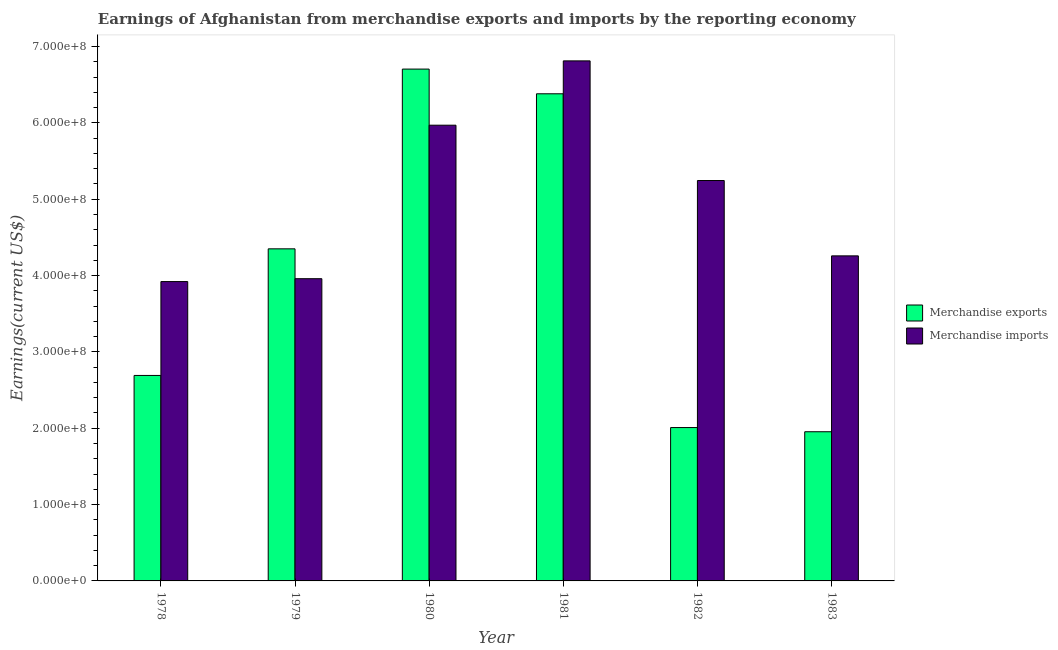How many different coloured bars are there?
Your answer should be very brief. 2. Are the number of bars on each tick of the X-axis equal?
Provide a succinct answer. Yes. How many bars are there on the 1st tick from the left?
Your answer should be compact. 2. What is the label of the 2nd group of bars from the left?
Keep it short and to the point. 1979. What is the earnings from merchandise exports in 1982?
Ensure brevity in your answer.  2.01e+08. Across all years, what is the maximum earnings from merchandise exports?
Provide a succinct answer. 6.70e+08. Across all years, what is the minimum earnings from merchandise imports?
Offer a very short reply. 3.92e+08. In which year was the earnings from merchandise exports maximum?
Ensure brevity in your answer.  1980. In which year was the earnings from merchandise imports minimum?
Keep it short and to the point. 1978. What is the total earnings from merchandise exports in the graph?
Provide a succinct answer. 2.41e+09. What is the difference between the earnings from merchandise imports in 1978 and that in 1980?
Your answer should be very brief. -2.05e+08. What is the difference between the earnings from merchandise imports in 1981 and the earnings from merchandise exports in 1982?
Your response must be concise. 1.57e+08. What is the average earnings from merchandise exports per year?
Keep it short and to the point. 4.02e+08. In the year 1982, what is the difference between the earnings from merchandise imports and earnings from merchandise exports?
Ensure brevity in your answer.  0. In how many years, is the earnings from merchandise imports greater than 400000000 US$?
Keep it short and to the point. 4. What is the ratio of the earnings from merchandise exports in 1978 to that in 1982?
Give a very brief answer. 1.34. Is the earnings from merchandise imports in 1979 less than that in 1981?
Your answer should be very brief. Yes. Is the difference between the earnings from merchandise imports in 1979 and 1981 greater than the difference between the earnings from merchandise exports in 1979 and 1981?
Make the answer very short. No. What is the difference between the highest and the second highest earnings from merchandise exports?
Offer a terse response. 3.24e+07. What is the difference between the highest and the lowest earnings from merchandise exports?
Ensure brevity in your answer.  4.75e+08. Is the sum of the earnings from merchandise exports in 1978 and 1983 greater than the maximum earnings from merchandise imports across all years?
Offer a very short reply. No. What does the 2nd bar from the right in 1981 represents?
Keep it short and to the point. Merchandise exports. Are all the bars in the graph horizontal?
Provide a succinct answer. No. How many years are there in the graph?
Give a very brief answer. 6. Does the graph contain any zero values?
Your answer should be very brief. No. Does the graph contain grids?
Provide a succinct answer. No. How are the legend labels stacked?
Provide a succinct answer. Vertical. What is the title of the graph?
Give a very brief answer. Earnings of Afghanistan from merchandise exports and imports by the reporting economy. Does "Age 65(female)" appear as one of the legend labels in the graph?
Your answer should be very brief. No. What is the label or title of the X-axis?
Keep it short and to the point. Year. What is the label or title of the Y-axis?
Ensure brevity in your answer.  Earnings(current US$). What is the Earnings(current US$) of Merchandise exports in 1978?
Your answer should be compact. 2.69e+08. What is the Earnings(current US$) of Merchandise imports in 1978?
Offer a very short reply. 3.92e+08. What is the Earnings(current US$) in Merchandise exports in 1979?
Your answer should be compact. 4.35e+08. What is the Earnings(current US$) in Merchandise imports in 1979?
Your answer should be compact. 3.96e+08. What is the Earnings(current US$) of Merchandise exports in 1980?
Make the answer very short. 6.70e+08. What is the Earnings(current US$) of Merchandise imports in 1980?
Give a very brief answer. 5.97e+08. What is the Earnings(current US$) in Merchandise exports in 1981?
Your answer should be compact. 6.38e+08. What is the Earnings(current US$) in Merchandise imports in 1981?
Your answer should be very brief. 6.81e+08. What is the Earnings(current US$) of Merchandise exports in 1982?
Keep it short and to the point. 2.01e+08. What is the Earnings(current US$) of Merchandise imports in 1982?
Your answer should be compact. 5.24e+08. What is the Earnings(current US$) in Merchandise exports in 1983?
Keep it short and to the point. 1.95e+08. What is the Earnings(current US$) in Merchandise imports in 1983?
Keep it short and to the point. 4.26e+08. Across all years, what is the maximum Earnings(current US$) in Merchandise exports?
Offer a very short reply. 6.70e+08. Across all years, what is the maximum Earnings(current US$) in Merchandise imports?
Provide a succinct answer. 6.81e+08. Across all years, what is the minimum Earnings(current US$) of Merchandise exports?
Your response must be concise. 1.95e+08. Across all years, what is the minimum Earnings(current US$) of Merchandise imports?
Provide a succinct answer. 3.92e+08. What is the total Earnings(current US$) of Merchandise exports in the graph?
Ensure brevity in your answer.  2.41e+09. What is the total Earnings(current US$) in Merchandise imports in the graph?
Make the answer very short. 3.02e+09. What is the difference between the Earnings(current US$) of Merchandise exports in 1978 and that in 1979?
Your answer should be very brief. -1.66e+08. What is the difference between the Earnings(current US$) in Merchandise imports in 1978 and that in 1979?
Offer a very short reply. -3.78e+06. What is the difference between the Earnings(current US$) of Merchandise exports in 1978 and that in 1980?
Keep it short and to the point. -4.01e+08. What is the difference between the Earnings(current US$) of Merchandise imports in 1978 and that in 1980?
Your answer should be compact. -2.05e+08. What is the difference between the Earnings(current US$) in Merchandise exports in 1978 and that in 1981?
Your answer should be very brief. -3.69e+08. What is the difference between the Earnings(current US$) of Merchandise imports in 1978 and that in 1981?
Provide a succinct answer. -2.89e+08. What is the difference between the Earnings(current US$) in Merchandise exports in 1978 and that in 1982?
Offer a very short reply. 6.83e+07. What is the difference between the Earnings(current US$) in Merchandise imports in 1978 and that in 1982?
Your response must be concise. -1.32e+08. What is the difference between the Earnings(current US$) of Merchandise exports in 1978 and that in 1983?
Your response must be concise. 7.38e+07. What is the difference between the Earnings(current US$) of Merchandise imports in 1978 and that in 1983?
Provide a short and direct response. -3.37e+07. What is the difference between the Earnings(current US$) of Merchandise exports in 1979 and that in 1980?
Keep it short and to the point. -2.35e+08. What is the difference between the Earnings(current US$) of Merchandise imports in 1979 and that in 1980?
Offer a very short reply. -2.01e+08. What is the difference between the Earnings(current US$) of Merchandise exports in 1979 and that in 1981?
Make the answer very short. -2.03e+08. What is the difference between the Earnings(current US$) in Merchandise imports in 1979 and that in 1981?
Your answer should be very brief. -2.85e+08. What is the difference between the Earnings(current US$) of Merchandise exports in 1979 and that in 1982?
Offer a terse response. 2.34e+08. What is the difference between the Earnings(current US$) of Merchandise imports in 1979 and that in 1982?
Your answer should be compact. -1.29e+08. What is the difference between the Earnings(current US$) of Merchandise exports in 1979 and that in 1983?
Provide a short and direct response. 2.40e+08. What is the difference between the Earnings(current US$) in Merchandise imports in 1979 and that in 1983?
Your answer should be compact. -2.99e+07. What is the difference between the Earnings(current US$) in Merchandise exports in 1980 and that in 1981?
Offer a terse response. 3.24e+07. What is the difference between the Earnings(current US$) of Merchandise imports in 1980 and that in 1981?
Give a very brief answer. -8.42e+07. What is the difference between the Earnings(current US$) of Merchandise exports in 1980 and that in 1982?
Keep it short and to the point. 4.70e+08. What is the difference between the Earnings(current US$) of Merchandise imports in 1980 and that in 1982?
Offer a terse response. 7.25e+07. What is the difference between the Earnings(current US$) in Merchandise exports in 1980 and that in 1983?
Provide a short and direct response. 4.75e+08. What is the difference between the Earnings(current US$) in Merchandise imports in 1980 and that in 1983?
Keep it short and to the point. 1.71e+08. What is the difference between the Earnings(current US$) in Merchandise exports in 1981 and that in 1982?
Your response must be concise. 4.37e+08. What is the difference between the Earnings(current US$) of Merchandise imports in 1981 and that in 1982?
Your answer should be very brief. 1.57e+08. What is the difference between the Earnings(current US$) of Merchandise exports in 1981 and that in 1983?
Your answer should be very brief. 4.43e+08. What is the difference between the Earnings(current US$) in Merchandise imports in 1981 and that in 1983?
Offer a terse response. 2.55e+08. What is the difference between the Earnings(current US$) in Merchandise exports in 1982 and that in 1983?
Your response must be concise. 5.49e+06. What is the difference between the Earnings(current US$) in Merchandise imports in 1982 and that in 1983?
Keep it short and to the point. 9.87e+07. What is the difference between the Earnings(current US$) of Merchandise exports in 1978 and the Earnings(current US$) of Merchandise imports in 1979?
Give a very brief answer. -1.27e+08. What is the difference between the Earnings(current US$) in Merchandise exports in 1978 and the Earnings(current US$) in Merchandise imports in 1980?
Give a very brief answer. -3.28e+08. What is the difference between the Earnings(current US$) in Merchandise exports in 1978 and the Earnings(current US$) in Merchandise imports in 1981?
Your answer should be very brief. -4.12e+08. What is the difference between the Earnings(current US$) in Merchandise exports in 1978 and the Earnings(current US$) in Merchandise imports in 1982?
Your answer should be very brief. -2.55e+08. What is the difference between the Earnings(current US$) of Merchandise exports in 1978 and the Earnings(current US$) of Merchandise imports in 1983?
Your answer should be compact. -1.57e+08. What is the difference between the Earnings(current US$) in Merchandise exports in 1979 and the Earnings(current US$) in Merchandise imports in 1980?
Provide a short and direct response. -1.62e+08. What is the difference between the Earnings(current US$) of Merchandise exports in 1979 and the Earnings(current US$) of Merchandise imports in 1981?
Offer a very short reply. -2.46e+08. What is the difference between the Earnings(current US$) in Merchandise exports in 1979 and the Earnings(current US$) in Merchandise imports in 1982?
Offer a very short reply. -8.95e+07. What is the difference between the Earnings(current US$) of Merchandise exports in 1979 and the Earnings(current US$) of Merchandise imports in 1983?
Your answer should be compact. 9.21e+06. What is the difference between the Earnings(current US$) in Merchandise exports in 1980 and the Earnings(current US$) in Merchandise imports in 1981?
Provide a short and direct response. -1.08e+07. What is the difference between the Earnings(current US$) of Merchandise exports in 1980 and the Earnings(current US$) of Merchandise imports in 1982?
Your answer should be compact. 1.46e+08. What is the difference between the Earnings(current US$) in Merchandise exports in 1980 and the Earnings(current US$) in Merchandise imports in 1983?
Offer a very short reply. 2.45e+08. What is the difference between the Earnings(current US$) in Merchandise exports in 1981 and the Earnings(current US$) in Merchandise imports in 1982?
Your response must be concise. 1.14e+08. What is the difference between the Earnings(current US$) of Merchandise exports in 1981 and the Earnings(current US$) of Merchandise imports in 1983?
Give a very brief answer. 2.12e+08. What is the difference between the Earnings(current US$) in Merchandise exports in 1982 and the Earnings(current US$) in Merchandise imports in 1983?
Provide a succinct answer. -2.25e+08. What is the average Earnings(current US$) in Merchandise exports per year?
Your answer should be very brief. 4.02e+08. What is the average Earnings(current US$) of Merchandise imports per year?
Give a very brief answer. 5.03e+08. In the year 1978, what is the difference between the Earnings(current US$) in Merchandise exports and Earnings(current US$) in Merchandise imports?
Give a very brief answer. -1.23e+08. In the year 1979, what is the difference between the Earnings(current US$) of Merchandise exports and Earnings(current US$) of Merchandise imports?
Give a very brief answer. 3.91e+07. In the year 1980, what is the difference between the Earnings(current US$) in Merchandise exports and Earnings(current US$) in Merchandise imports?
Your response must be concise. 7.35e+07. In the year 1981, what is the difference between the Earnings(current US$) in Merchandise exports and Earnings(current US$) in Merchandise imports?
Provide a succinct answer. -4.31e+07. In the year 1982, what is the difference between the Earnings(current US$) of Merchandise exports and Earnings(current US$) of Merchandise imports?
Ensure brevity in your answer.  -3.24e+08. In the year 1983, what is the difference between the Earnings(current US$) of Merchandise exports and Earnings(current US$) of Merchandise imports?
Your answer should be very brief. -2.30e+08. What is the ratio of the Earnings(current US$) in Merchandise exports in 1978 to that in 1979?
Offer a terse response. 0.62. What is the ratio of the Earnings(current US$) in Merchandise exports in 1978 to that in 1980?
Your response must be concise. 0.4. What is the ratio of the Earnings(current US$) in Merchandise imports in 1978 to that in 1980?
Offer a very short reply. 0.66. What is the ratio of the Earnings(current US$) in Merchandise exports in 1978 to that in 1981?
Ensure brevity in your answer.  0.42. What is the ratio of the Earnings(current US$) in Merchandise imports in 1978 to that in 1981?
Your answer should be compact. 0.58. What is the ratio of the Earnings(current US$) of Merchandise exports in 1978 to that in 1982?
Provide a short and direct response. 1.34. What is the ratio of the Earnings(current US$) in Merchandise imports in 1978 to that in 1982?
Your response must be concise. 0.75. What is the ratio of the Earnings(current US$) of Merchandise exports in 1978 to that in 1983?
Provide a succinct answer. 1.38. What is the ratio of the Earnings(current US$) in Merchandise imports in 1978 to that in 1983?
Make the answer very short. 0.92. What is the ratio of the Earnings(current US$) of Merchandise exports in 1979 to that in 1980?
Provide a succinct answer. 0.65. What is the ratio of the Earnings(current US$) in Merchandise imports in 1979 to that in 1980?
Your response must be concise. 0.66. What is the ratio of the Earnings(current US$) in Merchandise exports in 1979 to that in 1981?
Ensure brevity in your answer.  0.68. What is the ratio of the Earnings(current US$) of Merchandise imports in 1979 to that in 1981?
Ensure brevity in your answer.  0.58. What is the ratio of the Earnings(current US$) in Merchandise exports in 1979 to that in 1982?
Your answer should be very brief. 2.17. What is the ratio of the Earnings(current US$) of Merchandise imports in 1979 to that in 1982?
Your response must be concise. 0.75. What is the ratio of the Earnings(current US$) of Merchandise exports in 1979 to that in 1983?
Give a very brief answer. 2.23. What is the ratio of the Earnings(current US$) in Merchandise imports in 1979 to that in 1983?
Provide a short and direct response. 0.93. What is the ratio of the Earnings(current US$) in Merchandise exports in 1980 to that in 1981?
Provide a succinct answer. 1.05. What is the ratio of the Earnings(current US$) in Merchandise imports in 1980 to that in 1981?
Keep it short and to the point. 0.88. What is the ratio of the Earnings(current US$) in Merchandise exports in 1980 to that in 1982?
Provide a short and direct response. 3.34. What is the ratio of the Earnings(current US$) of Merchandise imports in 1980 to that in 1982?
Offer a very short reply. 1.14. What is the ratio of the Earnings(current US$) in Merchandise exports in 1980 to that in 1983?
Make the answer very short. 3.43. What is the ratio of the Earnings(current US$) in Merchandise imports in 1980 to that in 1983?
Provide a succinct answer. 1.4. What is the ratio of the Earnings(current US$) of Merchandise exports in 1981 to that in 1982?
Keep it short and to the point. 3.18. What is the ratio of the Earnings(current US$) in Merchandise imports in 1981 to that in 1982?
Provide a succinct answer. 1.3. What is the ratio of the Earnings(current US$) of Merchandise exports in 1981 to that in 1983?
Offer a terse response. 3.27. What is the ratio of the Earnings(current US$) of Merchandise imports in 1981 to that in 1983?
Provide a succinct answer. 1.6. What is the ratio of the Earnings(current US$) in Merchandise exports in 1982 to that in 1983?
Your answer should be compact. 1.03. What is the ratio of the Earnings(current US$) of Merchandise imports in 1982 to that in 1983?
Your answer should be very brief. 1.23. What is the difference between the highest and the second highest Earnings(current US$) in Merchandise exports?
Offer a terse response. 3.24e+07. What is the difference between the highest and the second highest Earnings(current US$) of Merchandise imports?
Your answer should be compact. 8.42e+07. What is the difference between the highest and the lowest Earnings(current US$) of Merchandise exports?
Give a very brief answer. 4.75e+08. What is the difference between the highest and the lowest Earnings(current US$) of Merchandise imports?
Make the answer very short. 2.89e+08. 